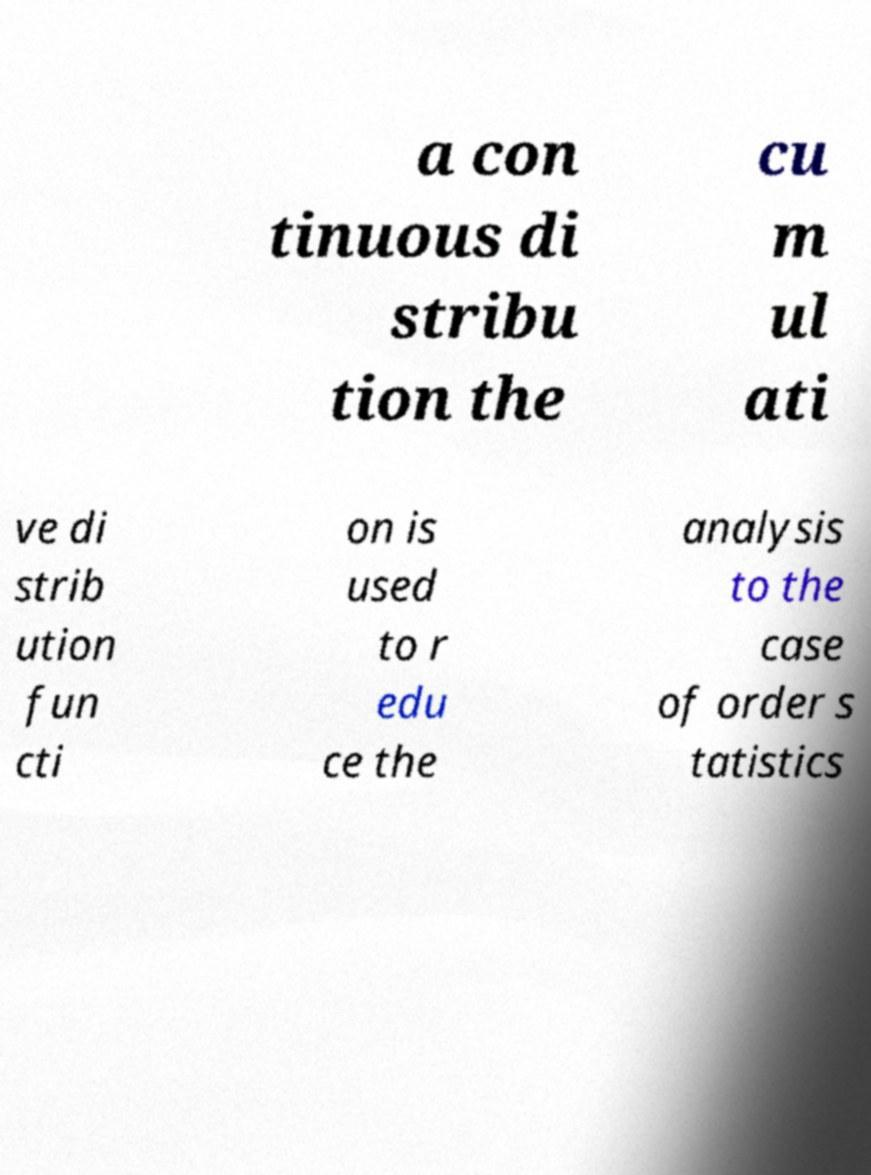For documentation purposes, I need the text within this image transcribed. Could you provide that? a con tinuous di stribu tion the cu m ul ati ve di strib ution fun cti on is used to r edu ce the analysis to the case of order s tatistics 